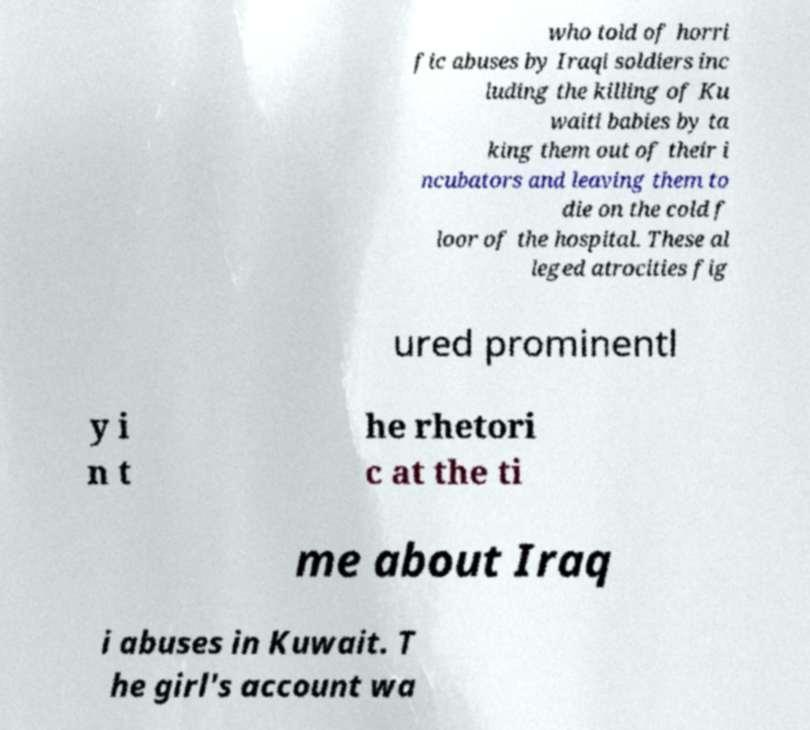Could you extract and type out the text from this image? who told of horri fic abuses by Iraqi soldiers inc luding the killing of Ku waiti babies by ta king them out of their i ncubators and leaving them to die on the cold f loor of the hospital. These al leged atrocities fig ured prominentl y i n t he rhetori c at the ti me about Iraq i abuses in Kuwait. T he girl's account wa 